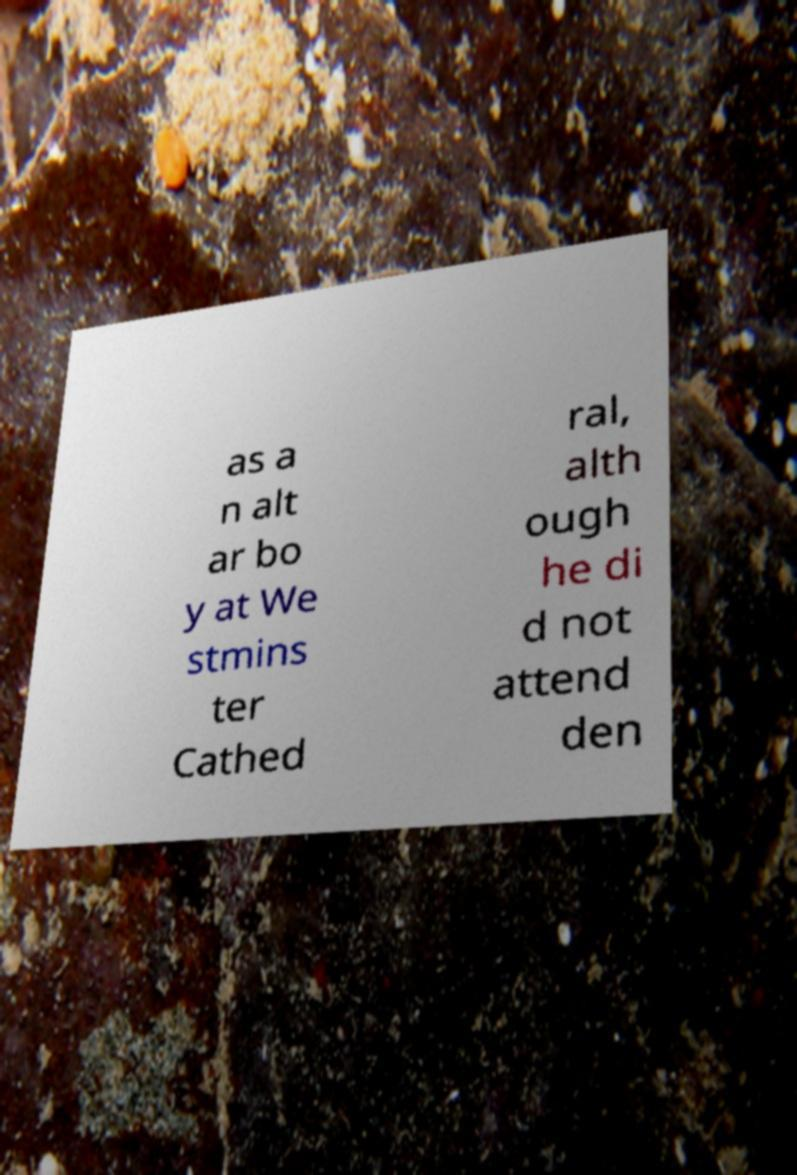Can you accurately transcribe the text from the provided image for me? as a n alt ar bo y at We stmins ter Cathed ral, alth ough he di d not attend den 